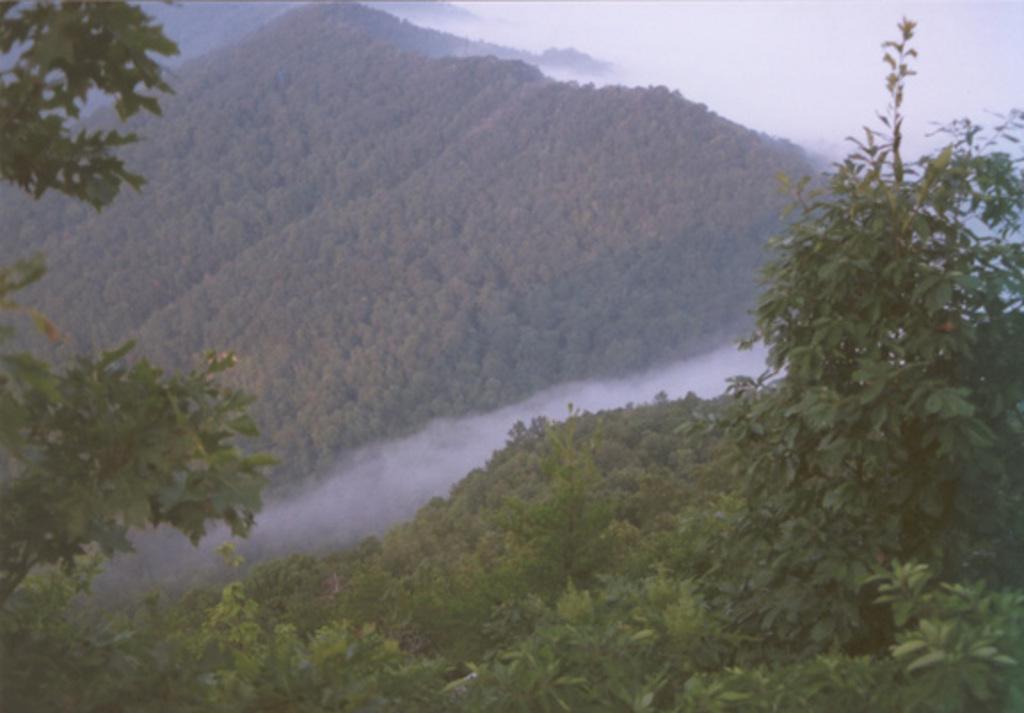Describe this image in one or two sentences. In this image I can see number of trees and clouds. 